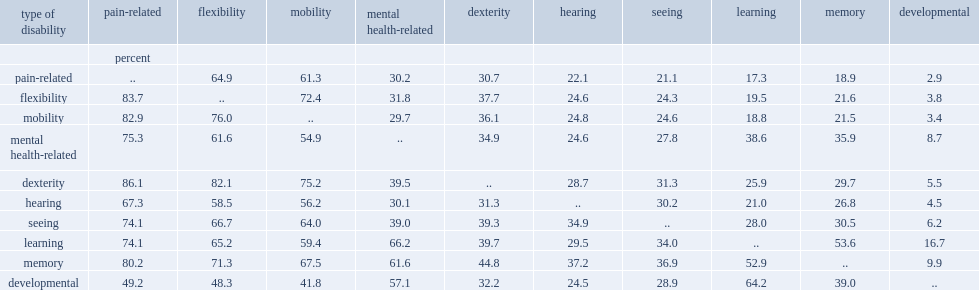Write the full table. {'header': ['type of disability', 'pain-related', 'flexibility', 'mobility', 'mental health-related', 'dexterity', 'hearing', 'seeing', 'learning', 'memory', 'developmental'], 'rows': [['', 'percent', '', '', '', '', '', '', '', '', ''], ['pain-related', '..', '64.9', '61.3', '30.2', '30.7', '22.1', '21.1', '17.3', '18.9', '2.9'], ['flexibility', '83.7', '..', '72.4', '31.8', '37.7', '24.6', '24.3', '19.5', '21.6', '3.8'], ['mobility', '82.9', '76.0', '..', '29.7', '36.1', '24.8', '24.6', '18.8', '21.5', '3.4'], ['mental health-related', '75.3', '61.6', '54.9', '..', '34.9', '24.6', '27.8', '38.6', '35.9', '8.7'], ['dexterity', '86.1', '82.1', '75.2', '39.5', '..', '28.7', '31.3', '25.9', '29.7', '5.5'], ['hearing', '67.3', '58.5', '56.2', '30.1', '31.3', '..', '30.2', '21.0', '26.8', '4.5'], ['seeing', '74.1', '66.7', '64.0', '39.0', '39.3', '34.9', '..', '28.0', '30.5', '6.2'], ['learning', '74.1', '65.2', '59.4', '66.2', '39.7', '29.5', '34.0', '..', '53.6', '16.7'], ['memory', '80.2', '71.3', '67.5', '61.6', '44.8', '37.2', '36.9', '52.9', '..', '9.9'], ['developmental', '49.2', '48.3', '41.8', '57.1', '32.2', '24.5', '28.9', '64.2', '39.0', '..']]} What is the percentage of individuals who report pain-related disabilities also reporting flexibility disabilities? 64.9. What is the percentage of individuals who report pain-related disabilities also reporting mobility disabilities? 61.3. 